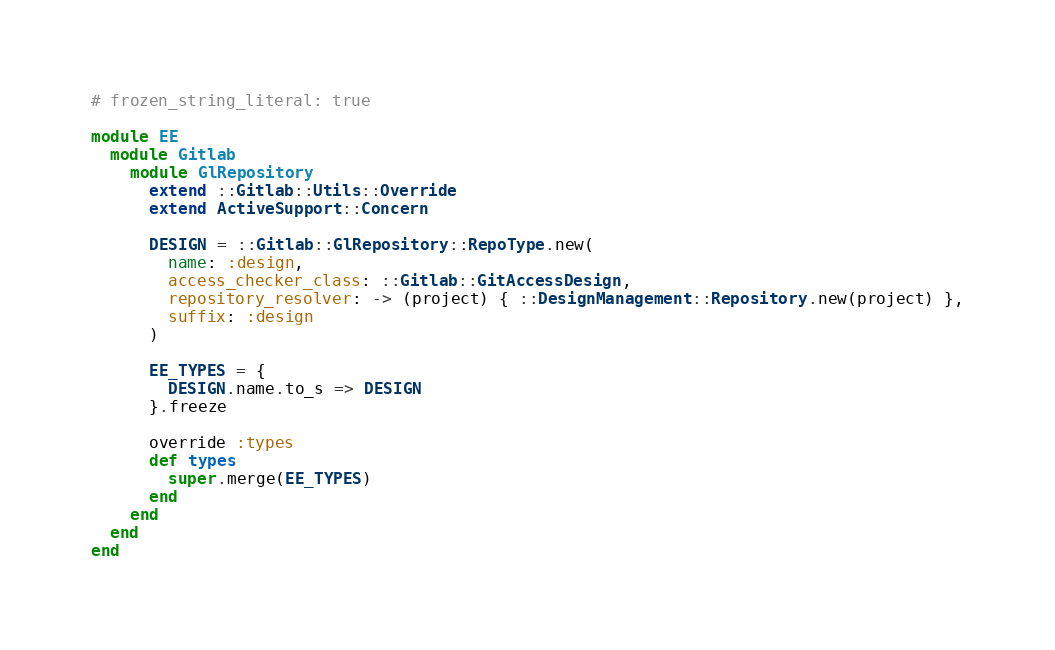Convert code to text. <code><loc_0><loc_0><loc_500><loc_500><_Ruby_># frozen_string_literal: true

module EE
  module Gitlab
    module GlRepository
      extend ::Gitlab::Utils::Override
      extend ActiveSupport::Concern

      DESIGN = ::Gitlab::GlRepository::RepoType.new(
        name: :design,
        access_checker_class: ::Gitlab::GitAccessDesign,
        repository_resolver: -> (project) { ::DesignManagement::Repository.new(project) },
        suffix: :design
      )

      EE_TYPES = {
        DESIGN.name.to_s => DESIGN
      }.freeze

      override :types
      def types
        super.merge(EE_TYPES)
      end
    end
  end
end
</code> 